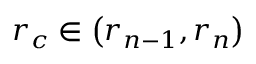Convert formula to latex. <formula><loc_0><loc_0><loc_500><loc_500>r _ { c } \in \left ( r _ { n - 1 } , r _ { n } \right )</formula> 